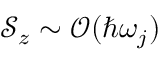<formula> <loc_0><loc_0><loc_500><loc_500>\mathcal { S } _ { z } \sim \mathcal { O } ( \hbar { \omega } _ { j } )</formula> 